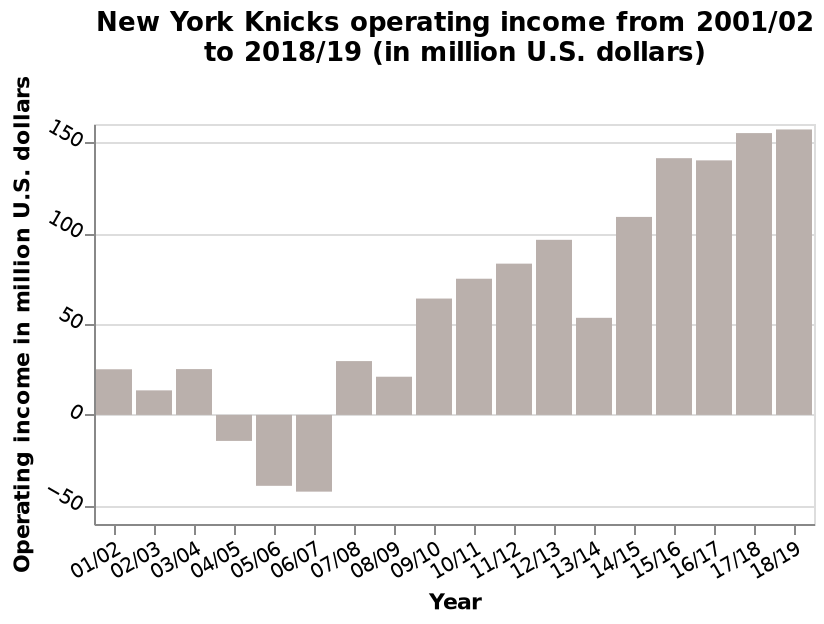<image>
Describe the following image in detail New York Knicks operating income from 2001/02 to 2018/19 (in million U.S. dollars) is a bar chart. The x-axis plots Year while the y-axis measures Operating income in million U.S. dollars. 